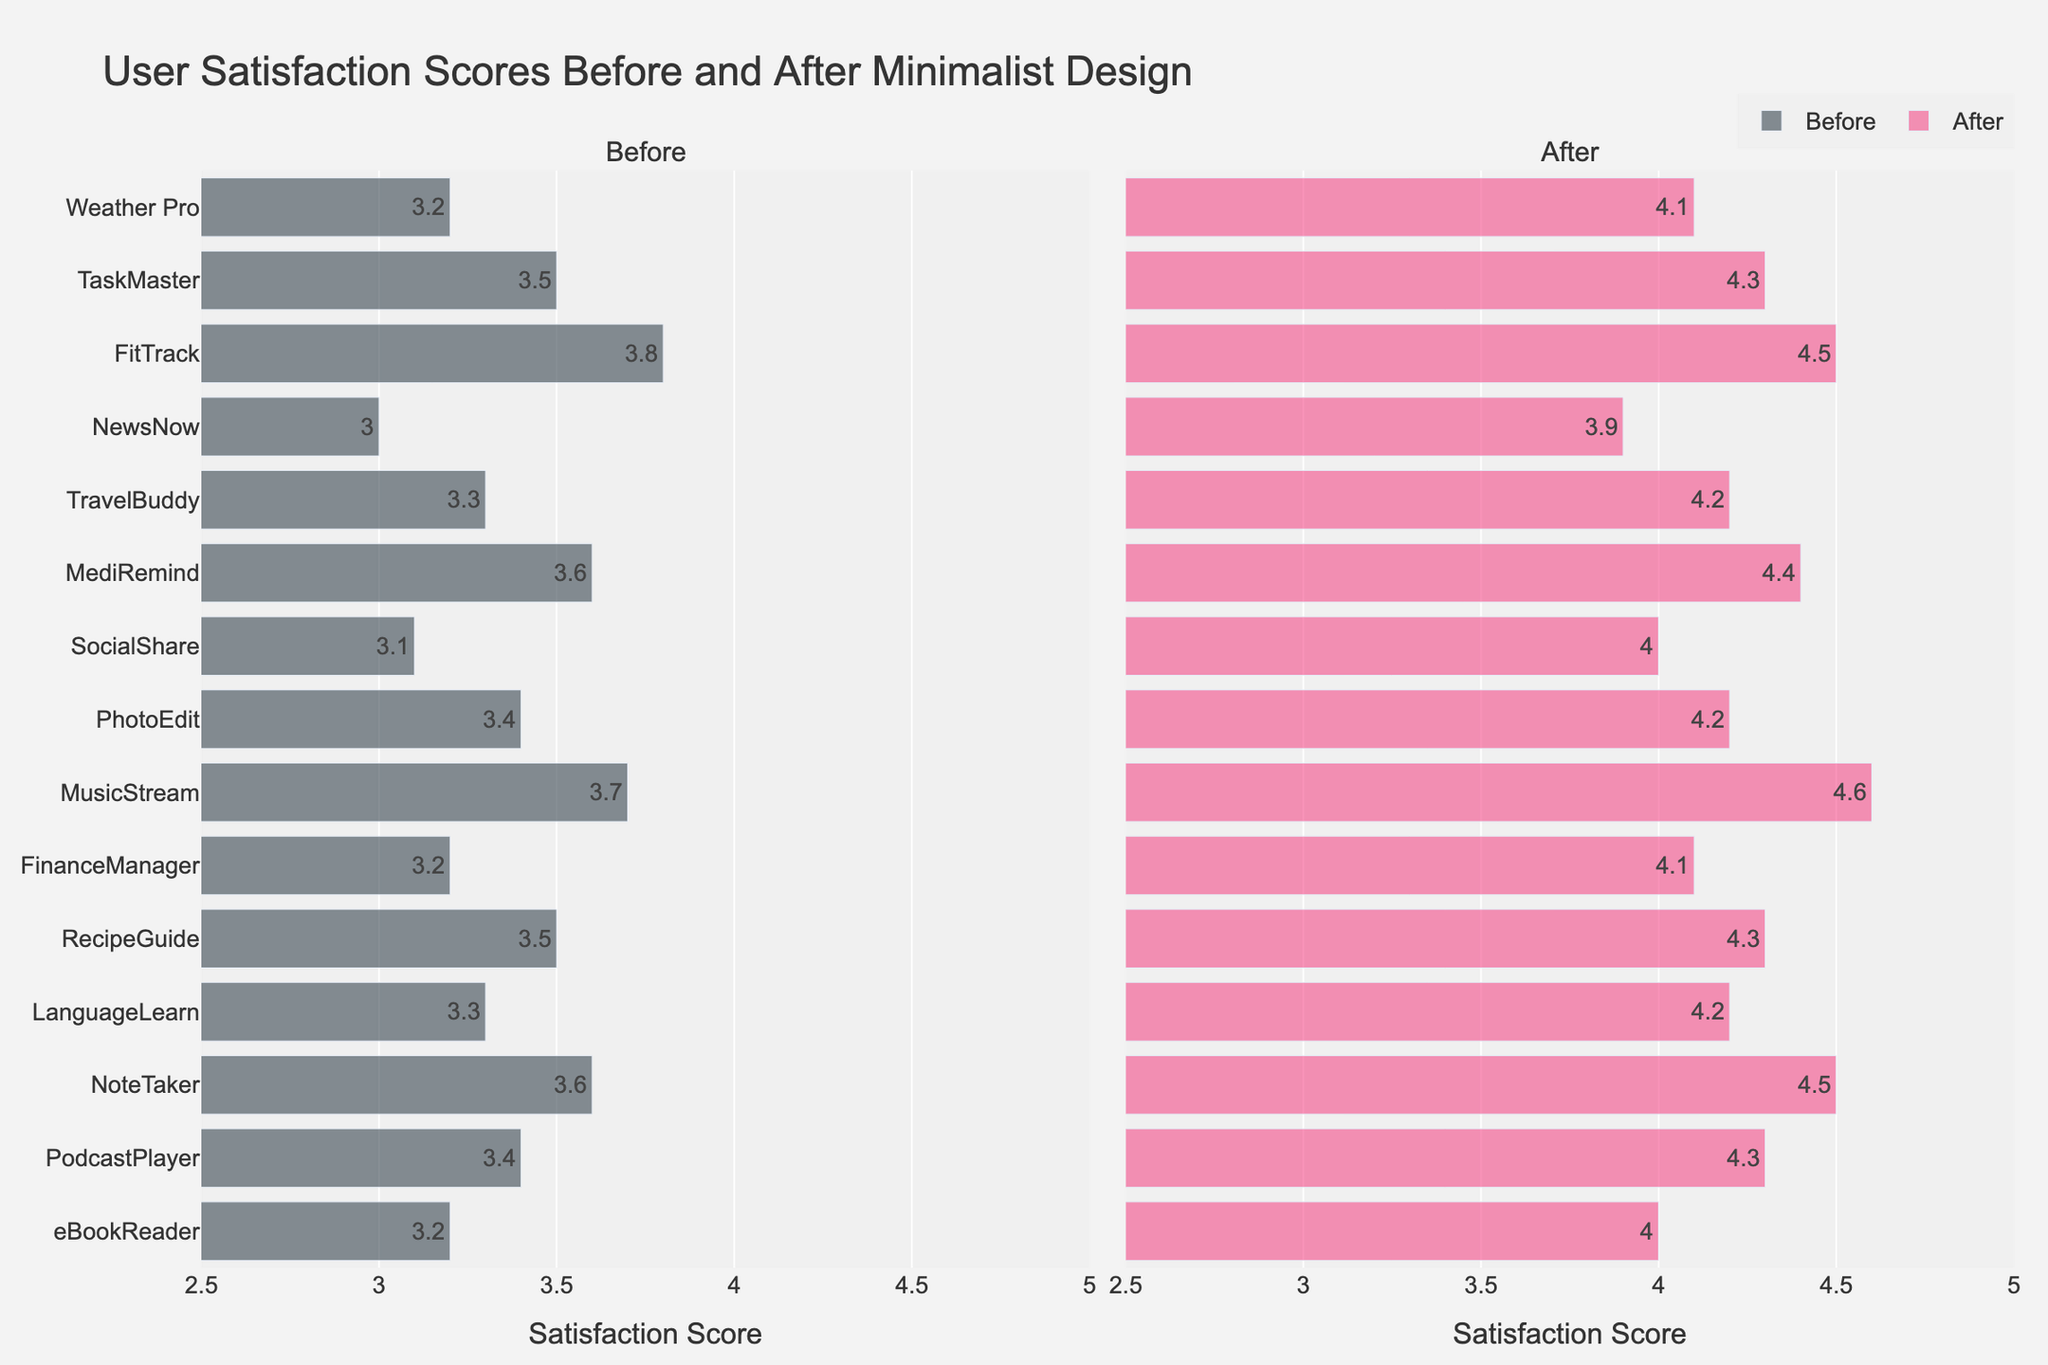What's the title of the figure? The title is displayed at the top of the figure, usually in a larger font size to make it prominent.
Answer: User Satisfaction Scores Before and After Minimalist Design How many mobile apps' user satisfaction scores are shown in the figure? Count each bar representing a mobile app's score on either the left or right side of the figure. Each mobile app corresponds to one bar in both the "Before" and "After" categories.
Answer: 15 What color represents the user satisfaction scores after implementing minimalist design? Identify the color of the bars on the right side of the figure, under the "After" label, which is distinct from the "Before" scores color.
Answer: Pink Which app showed the highest user satisfaction score after applying minimalist design, and what was the score? Locate the tallest bar on the right side of the figure, representing the "After" scores, and note the app name and the score displayed.
Answer: MusicStream, 4.6 Which app showed the least user satisfaction score before the minimalist design, and what was the score? Locate the shortest bar on the left side of the figure, representing the "Before" scores, and note the app name and the score displayed.
Answer: NewsNow, 3.0 Which mobile app had the smallest increase in user satisfaction score? Calculate the difference between each app's before and after scores, find the smallest difference, and note the corresponding app name.
Answer: FitTrack, 0.7 How many apps had a user satisfaction score of 4.5 or higher after implementing minimalist design? Count the number of bars on the right side of the figure with a satisfaction score of 4.5 or higher.
Answer: 3 